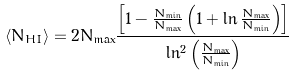Convert formula to latex. <formula><loc_0><loc_0><loc_500><loc_500>\langle N _ { H I } \rangle = 2 N _ { \max } \frac { \left [ 1 - \frac { N _ { \min } } { N _ { \max } } \left ( 1 + \ln \frac { N _ { \max } } { N _ { \min } } \right ) \right ] } { \ln ^ { 2 } \left ( \frac { N _ { \max } } { N _ { \min } } \right ) }</formula> 